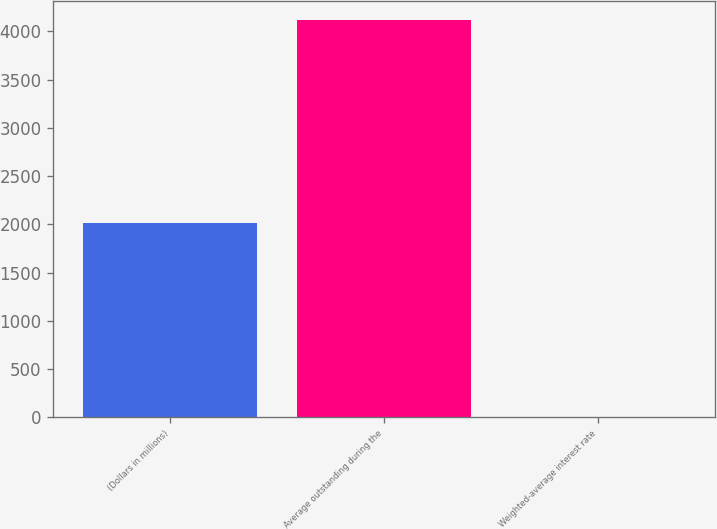Convert chart. <chart><loc_0><loc_0><loc_500><loc_500><bar_chart><fcel>(Dollars in millions)<fcel>Average outstanding during the<fcel>Weighted-average interest rate<nl><fcel>2016<fcel>4113<fcel>0.02<nl></chart> 